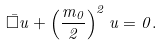<formula> <loc_0><loc_0><loc_500><loc_500>\bar { \Box } u + \left ( \frac { m _ { 0 } } { 2 } \right ) ^ { 2 } u = 0 .</formula> 